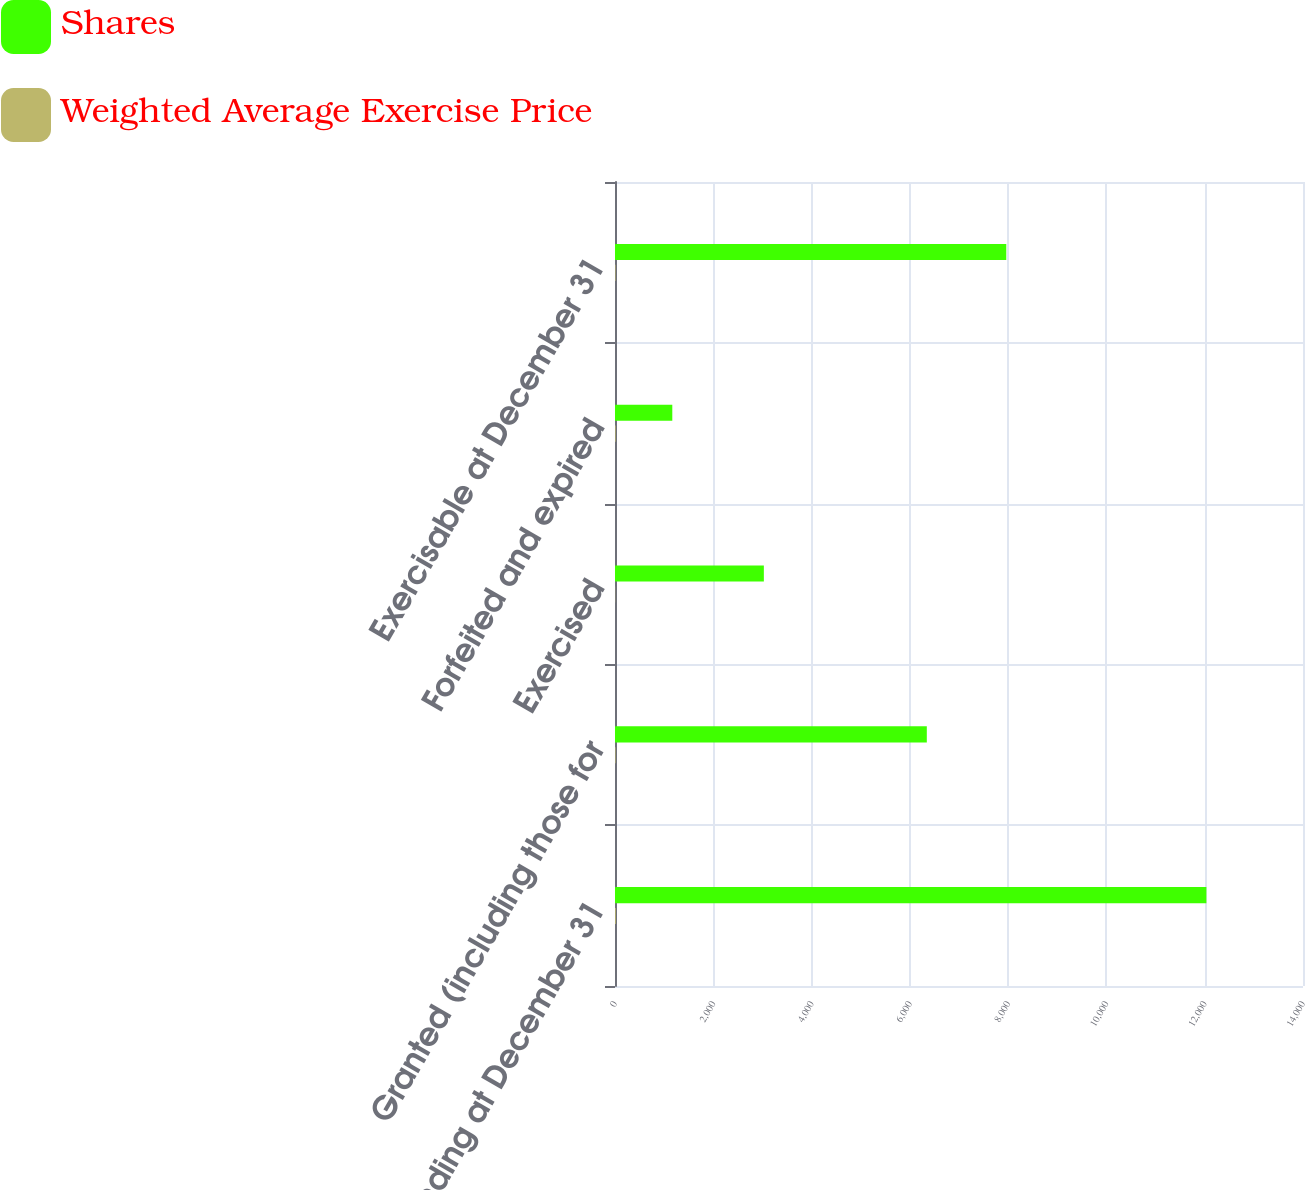Convert chart to OTSL. <chart><loc_0><loc_0><loc_500><loc_500><stacked_bar_chart><ecel><fcel>Outstanding at December 31<fcel>Granted (including those for<fcel>Exercised<fcel>Forfeited and expired<fcel>Exercisable at December 31<nl><fcel>Shares<fcel>12034<fcel>6345<fcel>3029<fcel>1166<fcel>7962<nl><fcel>Weighted Average Exercise Price<fcel>15.83<fcel>10.67<fcel>3.28<fcel>12.23<fcel>10.03<nl></chart> 